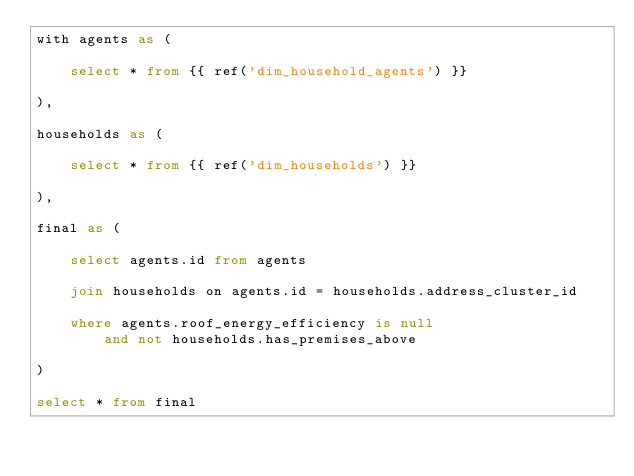<code> <loc_0><loc_0><loc_500><loc_500><_SQL_>with agents as (

    select * from {{ ref('dim_household_agents') }}

),

households as (

    select * from {{ ref('dim_households') }}

),

final as (

    select agents.id from agents

    join households on agents.id = households.address_cluster_id

    where agents.roof_energy_efficiency is null
        and not households.has_premises_above

)

select * from final
</code> 